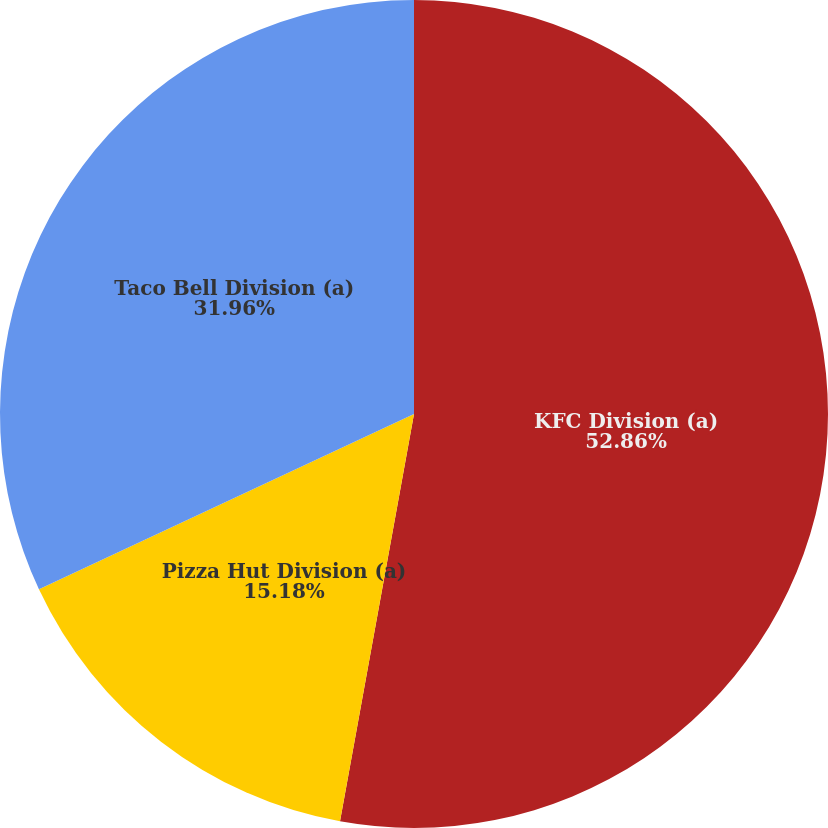Convert chart. <chart><loc_0><loc_0><loc_500><loc_500><pie_chart><fcel>KFC Division (a)<fcel>Pizza Hut Division (a)<fcel>Taco Bell Division (a)<nl><fcel>52.86%<fcel>15.18%<fcel>31.96%<nl></chart> 